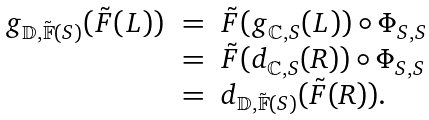Convert formula to latex. <formula><loc_0><loc_0><loc_500><loc_500>\begin{array} { l l l } g _ { \mathbb { D } , \tilde { \mathbb { F } } ( S ) } ( \tilde { F } ( L ) ) & = & \tilde { F } ( g _ { \mathbb { C } , S } ( L ) ) \circ \Phi _ { S , S } \\ & = & \tilde { F } ( d _ { \mathbb { C } , S } ( R ) ) \circ \Phi _ { S , S } \\ & = & d _ { \mathbb { D } , \tilde { \mathbb { F } } ( S ) } ( \tilde { F } ( R ) ) . \end{array}</formula> 